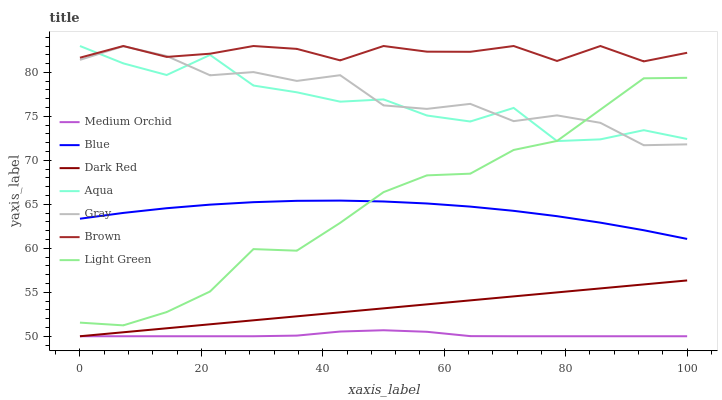Does Medium Orchid have the minimum area under the curve?
Answer yes or no. Yes. Does Brown have the maximum area under the curve?
Answer yes or no. Yes. Does Gray have the minimum area under the curve?
Answer yes or no. No. Does Gray have the maximum area under the curve?
Answer yes or no. No. Is Dark Red the smoothest?
Answer yes or no. Yes. Is Aqua the roughest?
Answer yes or no. Yes. Is Brown the smoothest?
Answer yes or no. No. Is Brown the roughest?
Answer yes or no. No. Does Dark Red have the lowest value?
Answer yes or no. Yes. Does Gray have the lowest value?
Answer yes or no. No. Does Aqua have the highest value?
Answer yes or no. Yes. Does Gray have the highest value?
Answer yes or no. No. Is Medium Orchid less than Gray?
Answer yes or no. Yes. Is Light Green greater than Dark Red?
Answer yes or no. Yes. Does Gray intersect Brown?
Answer yes or no. Yes. Is Gray less than Brown?
Answer yes or no. No. Is Gray greater than Brown?
Answer yes or no. No. Does Medium Orchid intersect Gray?
Answer yes or no. No. 